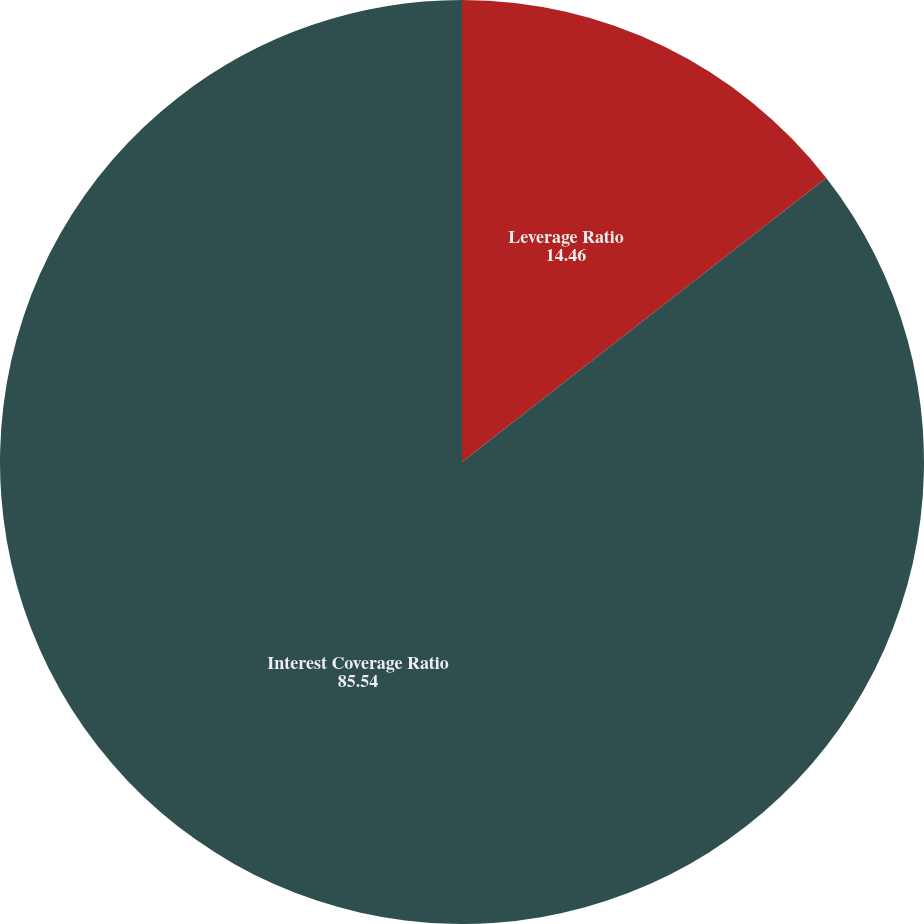Convert chart. <chart><loc_0><loc_0><loc_500><loc_500><pie_chart><fcel>Leverage Ratio<fcel>Interest Coverage Ratio<nl><fcel>14.46%<fcel>85.54%<nl></chart> 